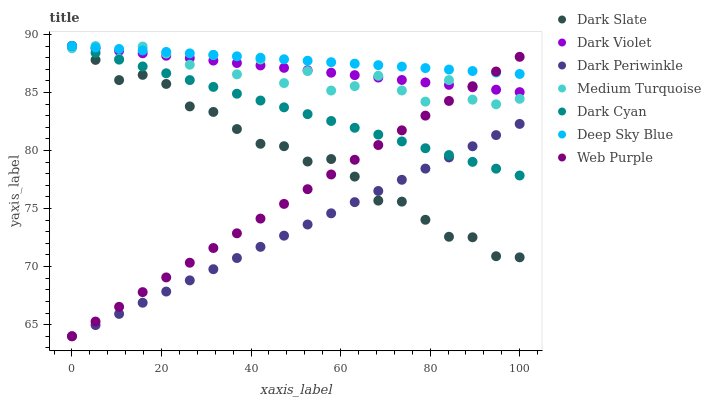Does Dark Periwinkle have the minimum area under the curve?
Answer yes or no. Yes. Does Deep Sky Blue have the maximum area under the curve?
Answer yes or no. Yes. Does Dark Violet have the minimum area under the curve?
Answer yes or no. No. Does Dark Violet have the maximum area under the curve?
Answer yes or no. No. Is Dark Periwinkle the smoothest?
Answer yes or no. Yes. Is Medium Turquoise the roughest?
Answer yes or no. Yes. Is Dark Violet the smoothest?
Answer yes or no. No. Is Dark Violet the roughest?
Answer yes or no. No. Does Web Purple have the lowest value?
Answer yes or no. Yes. Does Dark Violet have the lowest value?
Answer yes or no. No. Does Dark Cyan have the highest value?
Answer yes or no. Yes. Does Dark Slate have the highest value?
Answer yes or no. No. Is Dark Slate less than Deep Sky Blue?
Answer yes or no. Yes. Is Dark Violet greater than Dark Periwinkle?
Answer yes or no. Yes. Does Medium Turquoise intersect Dark Slate?
Answer yes or no. Yes. Is Medium Turquoise less than Dark Slate?
Answer yes or no. No. Is Medium Turquoise greater than Dark Slate?
Answer yes or no. No. Does Dark Slate intersect Deep Sky Blue?
Answer yes or no. No. 